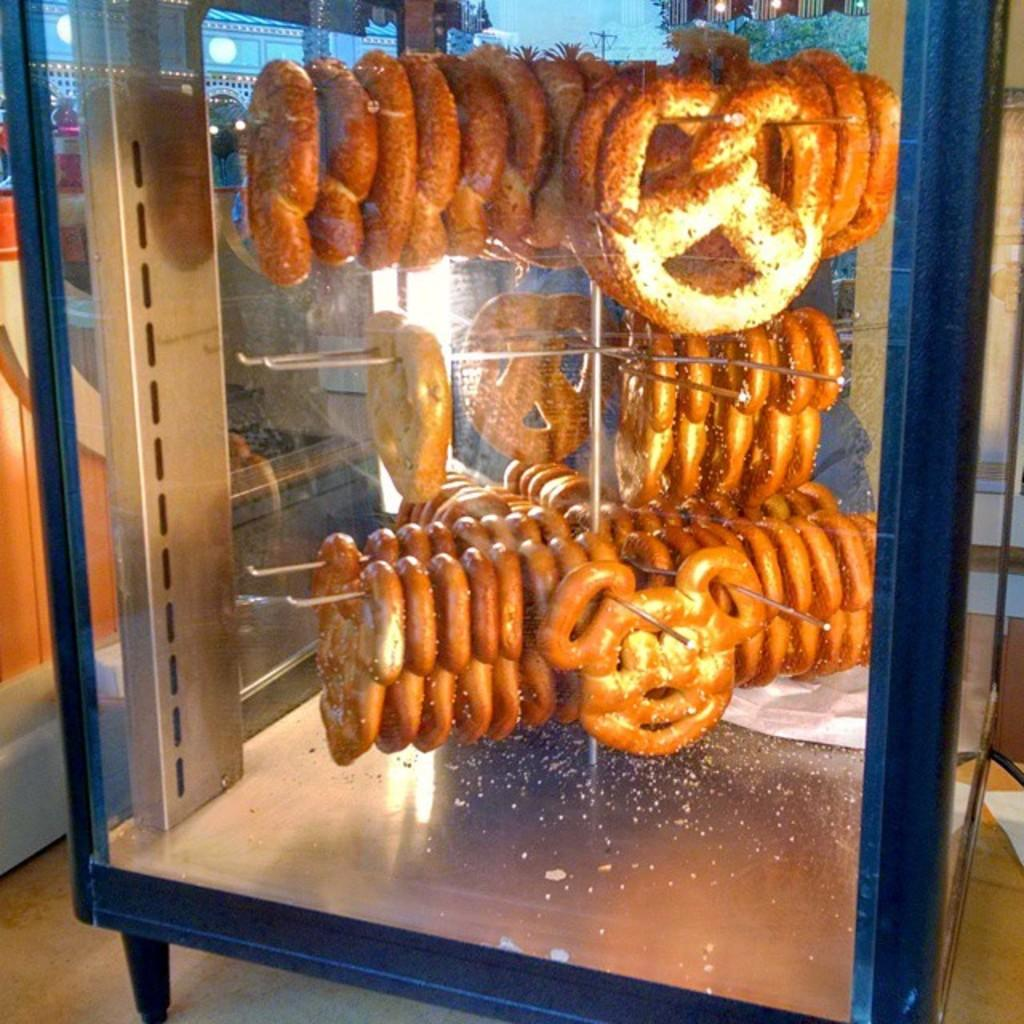Where was the image taken? The image was taken indoors. What can be seen at the bottom of the image? There is a floor visible at the bottom of the image. What is in the background of the image? There is a wall in the background of the image. What is located in the middle of the image? There are food items in a box in the middle of the image. What type of cake is being served in the hall in the image? There is no cake or hall present in the image; it features food items in a box indoors. What mathematical operation is being performed on the food items in the image? There is no addition or any other mathematical operation being performed on the food items in the image. 